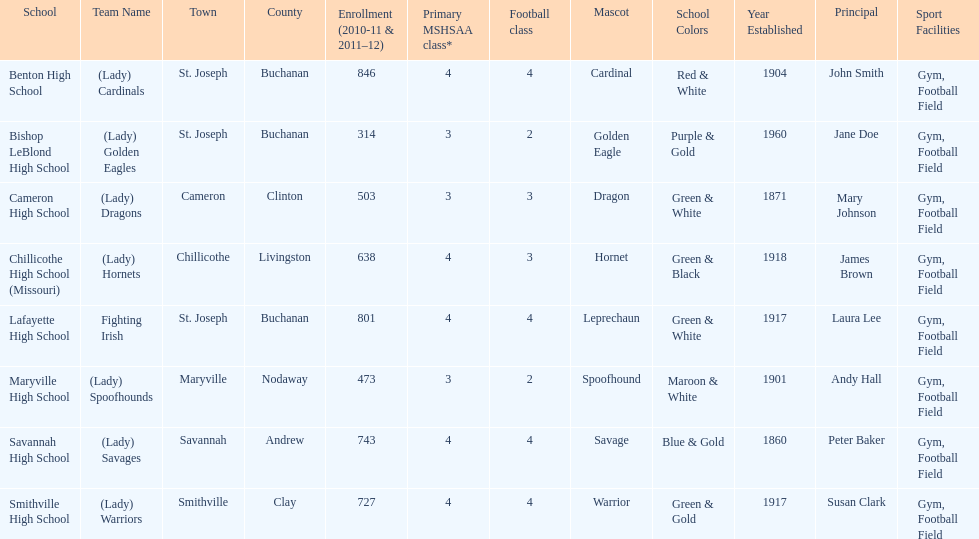How many schools are there in this conference? 8. 